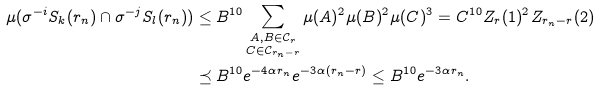<formula> <loc_0><loc_0><loc_500><loc_500>\mu ( \sigma ^ { - i } S _ { k } ( r _ { n } ) \cap \sigma ^ { - j } S _ { l } ( r _ { n } ) ) & \leq B ^ { 1 0 } \sum _ { \substack { A , B \in \mathcal { C } _ { r } \\ C \in \mathcal { C } _ { r _ { n } - r } } } \mu ( A ) ^ { 2 } \mu ( B ) ^ { 2 } \mu ( C ) ^ { 3 } = C ^ { 1 0 } Z _ { r } ( 1 ) ^ { 2 } Z _ { r _ { n } - r } ( 2 ) \\ & \preceq B ^ { 1 0 } e ^ { - 4 \alpha r _ { n } } e ^ { - 3 \alpha ( r _ { n } - r ) } \leq B ^ { 1 0 } e ^ { - 3 \alpha r _ { n } } .</formula> 